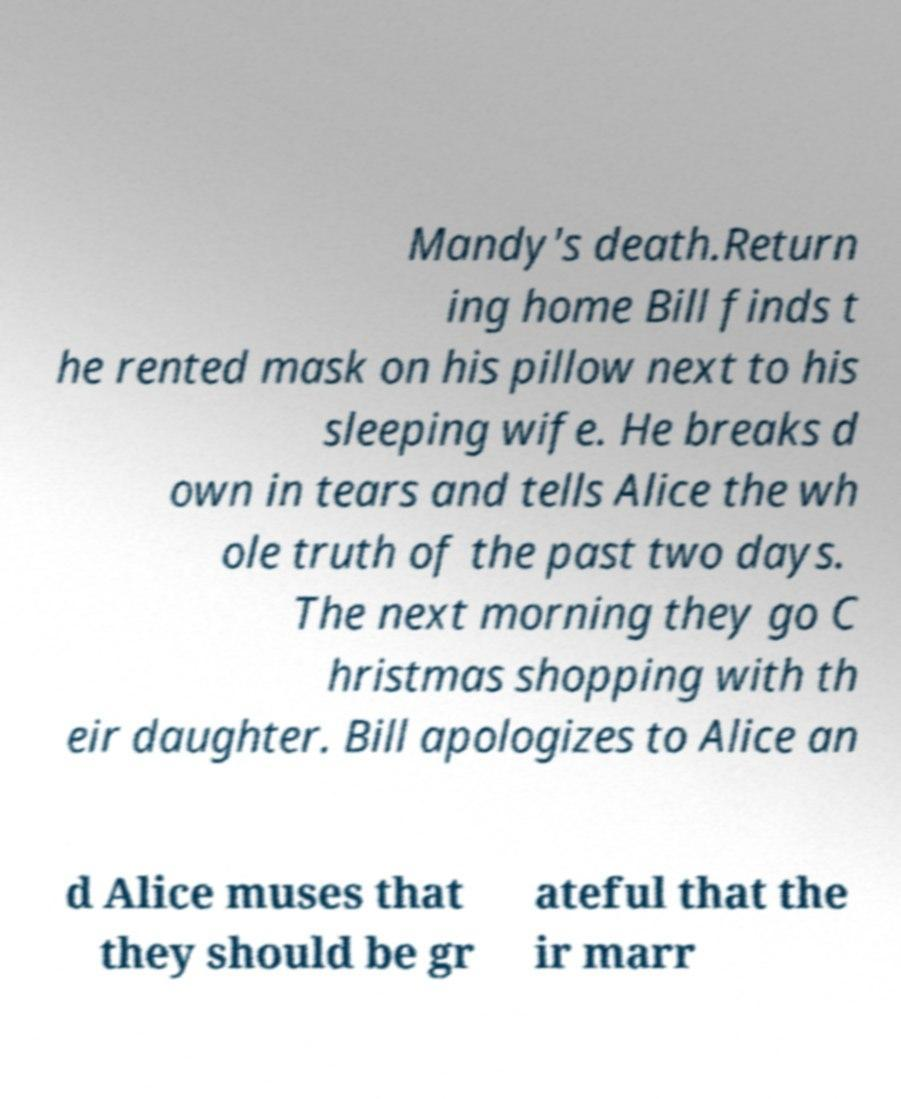There's text embedded in this image that I need extracted. Can you transcribe it verbatim? Mandy's death.Return ing home Bill finds t he rented mask on his pillow next to his sleeping wife. He breaks d own in tears and tells Alice the wh ole truth of the past two days. The next morning they go C hristmas shopping with th eir daughter. Bill apologizes to Alice an d Alice muses that they should be gr ateful that the ir marr 